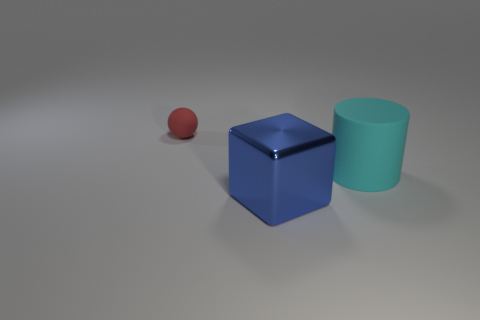Add 1 large red objects. How many objects exist? 4 Subtract all blocks. How many objects are left? 2 Subtract all cylinders. Subtract all small cyan cylinders. How many objects are left? 2 Add 2 blue metallic things. How many blue metallic things are left? 3 Add 3 red spheres. How many red spheres exist? 4 Subtract 1 red spheres. How many objects are left? 2 